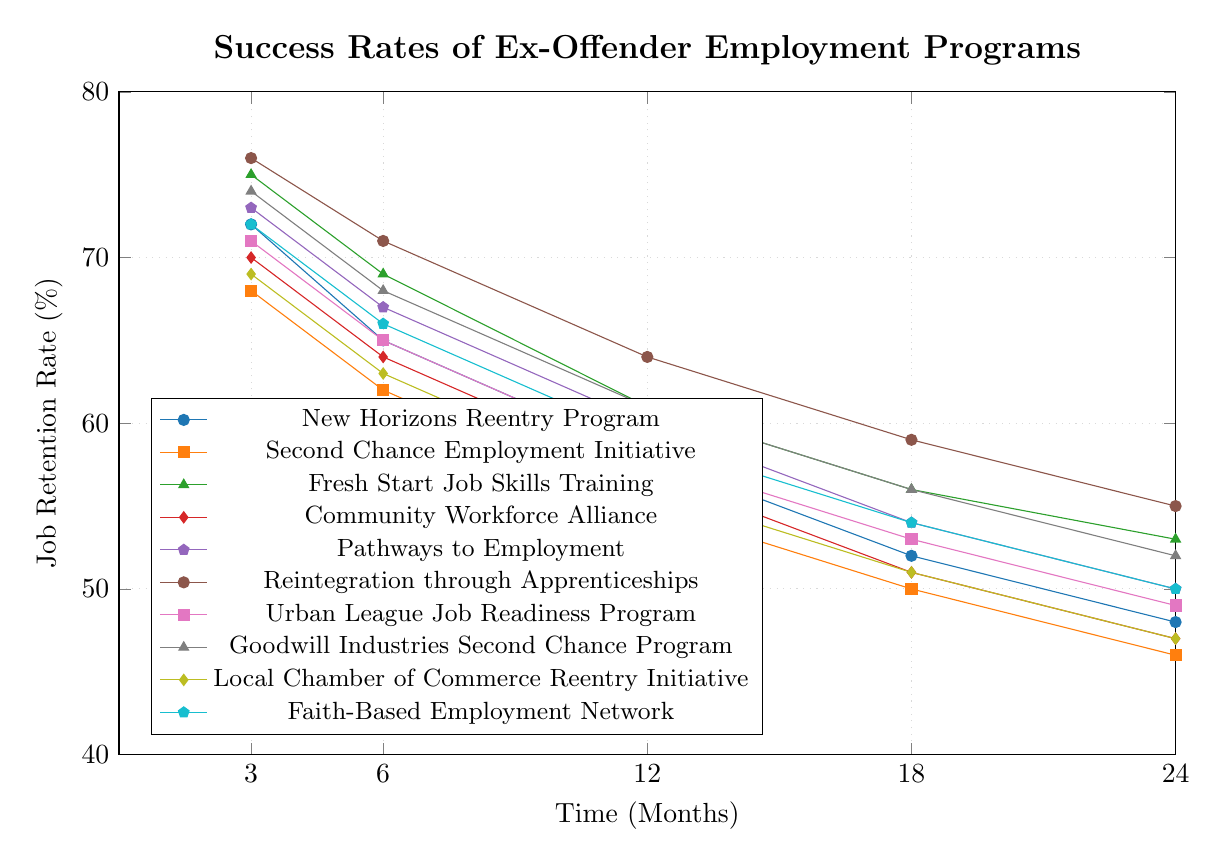What program has the highest job retention rate at 3 months? Look at the values on the plot at the 3-month mark and identify the highest value. The Reintegration through Apprenticeships program has a job retention rate of 76%, which is the highest among all the programs.
Answer: Reintegration through Apprenticeships Which program shows the least decline in job retention rate from 3 to 24 months? Calculate the difference in job retention rates at 3 months and 24 months for each program. The Reintegration through Apprenticeships program has the smallest decline (76% - 55% = 21%).
Answer: Reintegration through Apprenticeships Between 12 months and 24 months, which program has the largest decline in job retention rate? Determine the job retention rates at 12 months and 24 months for each program. Calculate the differences and identify the largest one. The Fresh Start Job Skills Training program has the largest decline (61% - 53% = 8%).
Answer: Fresh Start Job Skills Training At 18 months, which two programs have the same job retention rate? Look at the values at the 18-month mark and find any programs with the same job retention rate. Both the Pathways to Employment and the Faith-Based Employment Network have a rate of 54%.
Answer: Pathways to Employment and Faith-Based Employment Network What is the average job retention rate at 6 months for all programs? Add the job retention rates at 6 months for all programs and divide by the number of programs. The rates are: 65, 62, 69, 64, 67, 71, 65, 68, 63, 66. Sum these to get 660, then divide by 10.
Answer: 66% Which program has the most consistent decline in job retention rate over time? Analyze the intervals between the data points for each program. Look for the program where the differences between each time point are similar. The Community Workforce Alliance declines consistently (70, 64, 57, 51, 47).
Answer: Community Workforce Alliance Compare the job retention rates at 12 months for Faith-Based Employment Network and Goodwill Industries Second Chance Program. Which one is higher? Look at the values at the 12-month mark for both programs. Faith-Based Employment Network is 59% and Goodwill Industries Second Chance Program is 61%.
Answer: Goodwill Industries Second Chance Program For which program has job retention dropped below 50% by 24 months? Check the values at the 24-month mark for each program. Both Second Chance Employment Initiative (46%) and Community Workforce Alliance (47%) have rates below 50%.
Answer: Second Chance Employment Initiative and Community Workforce Alliance 